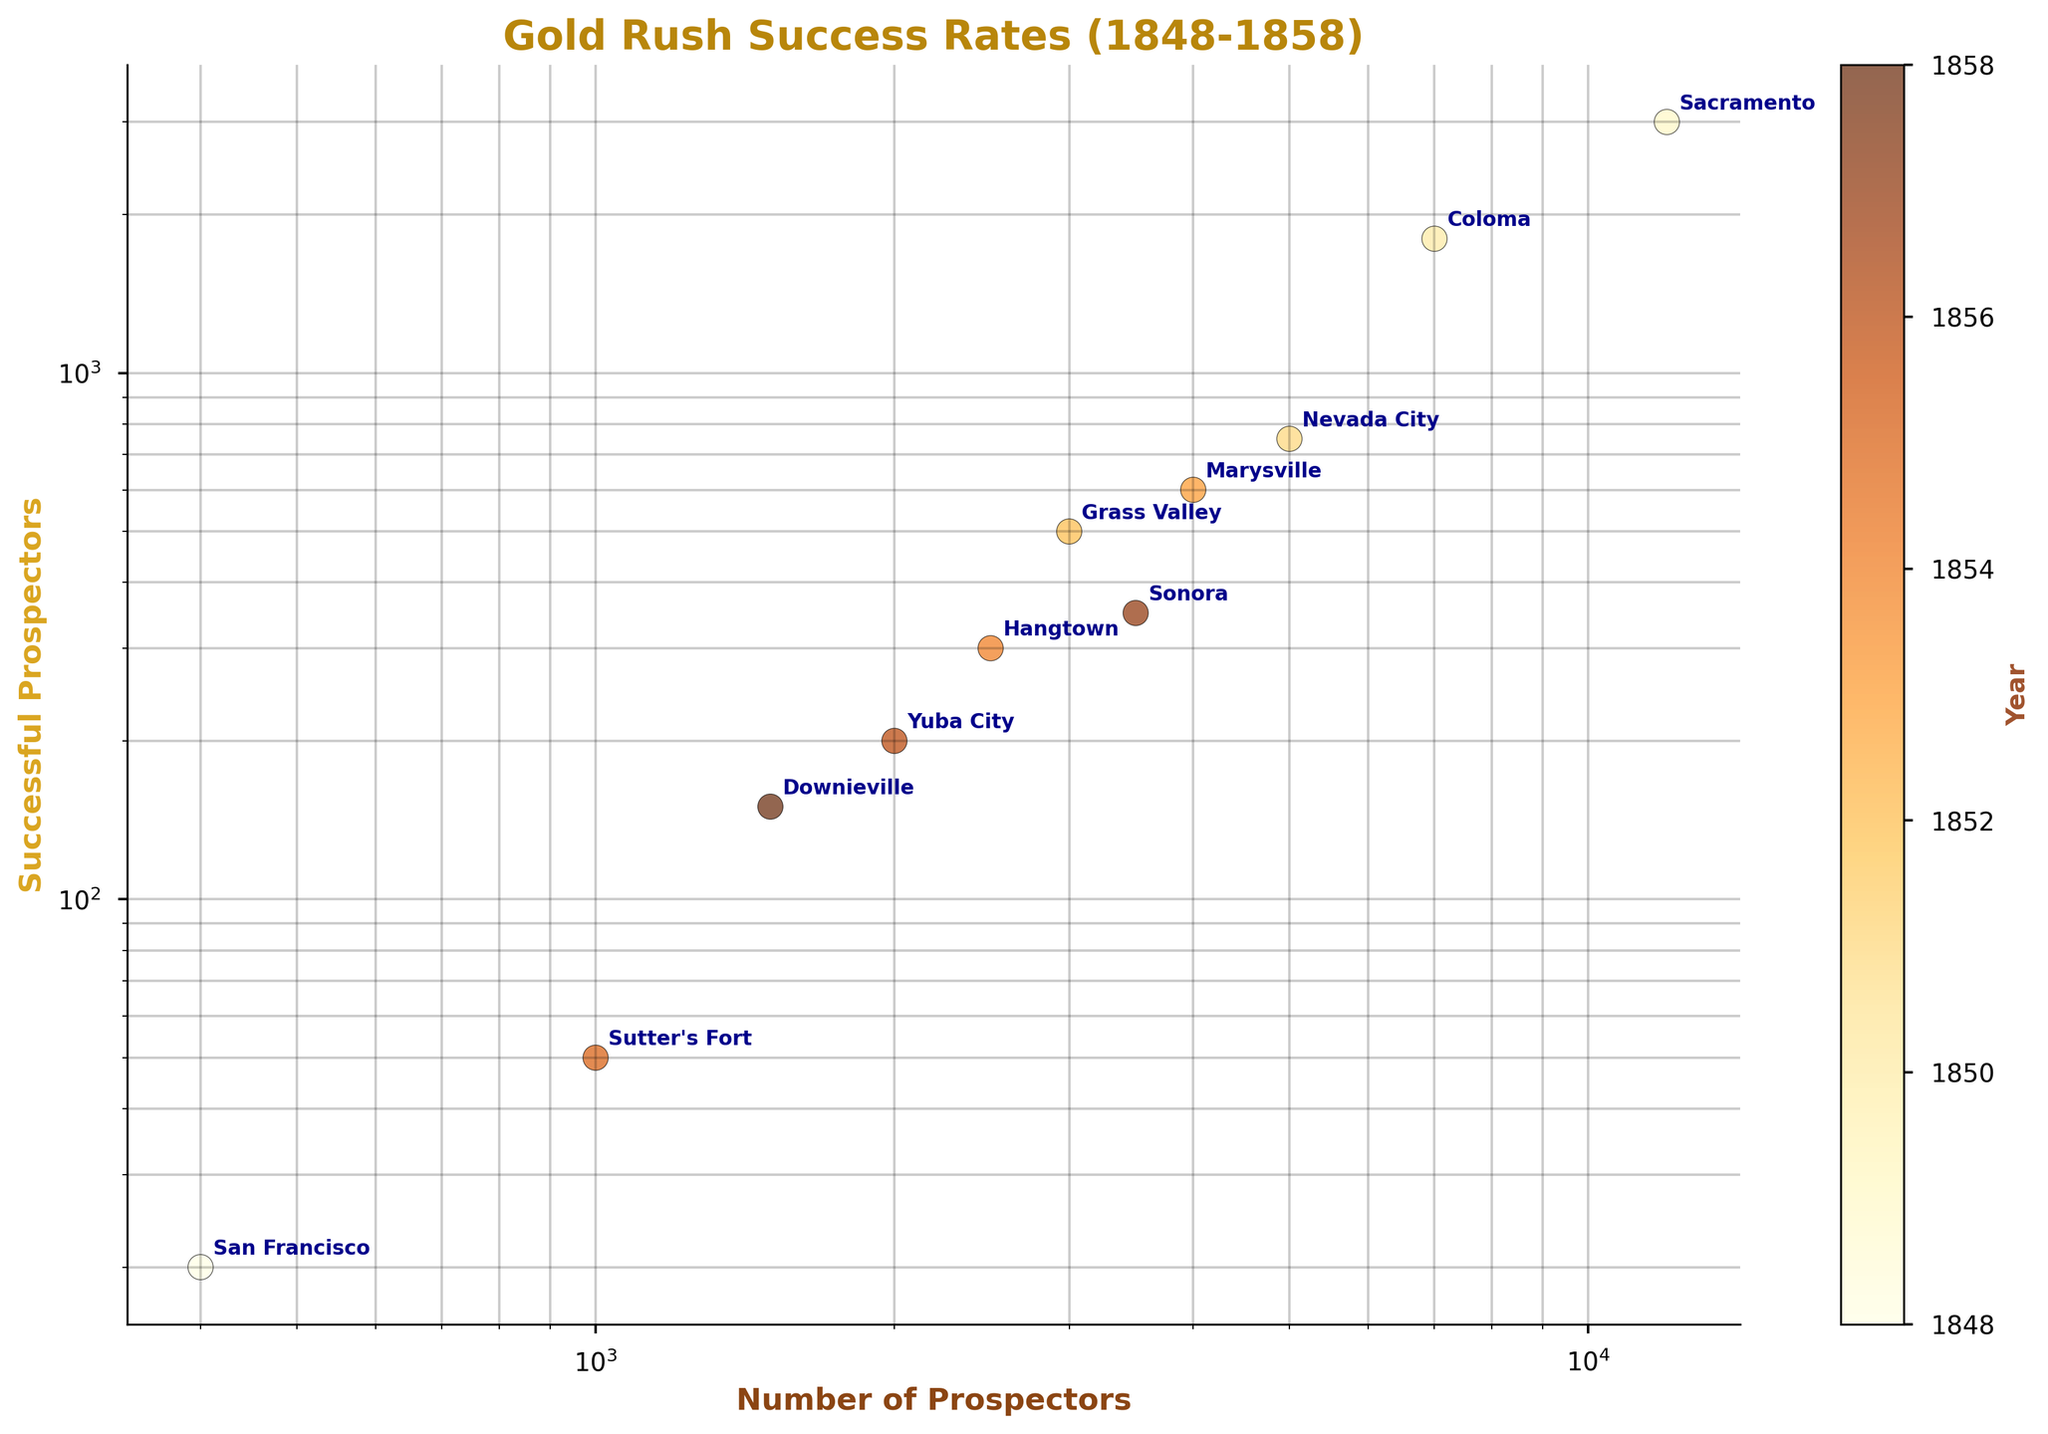What is the title of the plot? The title of the plot is typically displayed at the top center of the figure. By looking at this section, one can read the title clearly and interpret it.
Answer: Gold Rush Success Rates (1848-1858) What do the x and y axes represent? The x-axis typically represents 'Number of Prospectors,' while the y-axis represents 'Successful Prospectors.' These labels are normally placed along the respective axes.
Answer: Number of Prospectors and Successful Prospectors Which city had the highest number of prospectors? By examining the locations of the data points along the x-axis, we can identify the city positioned farthest to the right. This city will have the highest number of prospectors.
Answer: Sacramento Which city had the lowest number of successful prospectors? By examining the data points along the y-axis, we can identify the city positioned closest to the bottom of the plot. This city will have the lowest number of successful prospectors.
Answer: Sutter's Fort What does the color gradient represent in the plot? The color gradient, often represented by a color bar or legend, indicates a certain variable—in this case, the year. By examining the color bar on the side, one can determine what the different colors correspond to.
Answer: Year Which city in the year 1849 had the highest number of successful prospectors? To answer this, identify the data point with the color corresponding to the year 1849 on the color gradient and find its position on the y-axis. The city closest to the top will have the highest number of successful prospectors.
Answer: Sacramento What's the approximate success rate (as a percentage) for the city with 3000 prospectors? Identify the data point corresponding to 3000 prospectors along the x-axis, then locate its y-coordinate for successful prospectors. Calculate the successful prospectors divided by the total prospectors, multiplied by 100 to get the percentage.
Answer: (500/3000) * 100 = 16.67% Which city among San Francisco, Grass Valley, and Hangtown had the highest success rate? Calculate the success rate for each city by dividing the number of successful prospectors by the total number of prospectors, then compare these rates.
Answer: San Francisco Is there a general trend between the number of prospectors and successful prospectors? By visually examining the spread and direction of the data points on the plot, determine if there's a pattern suggesting a relationship between the number of prospectors and the number of successful ones.
Answer: Yes, more prospectors generally lead to more successful prospectors 